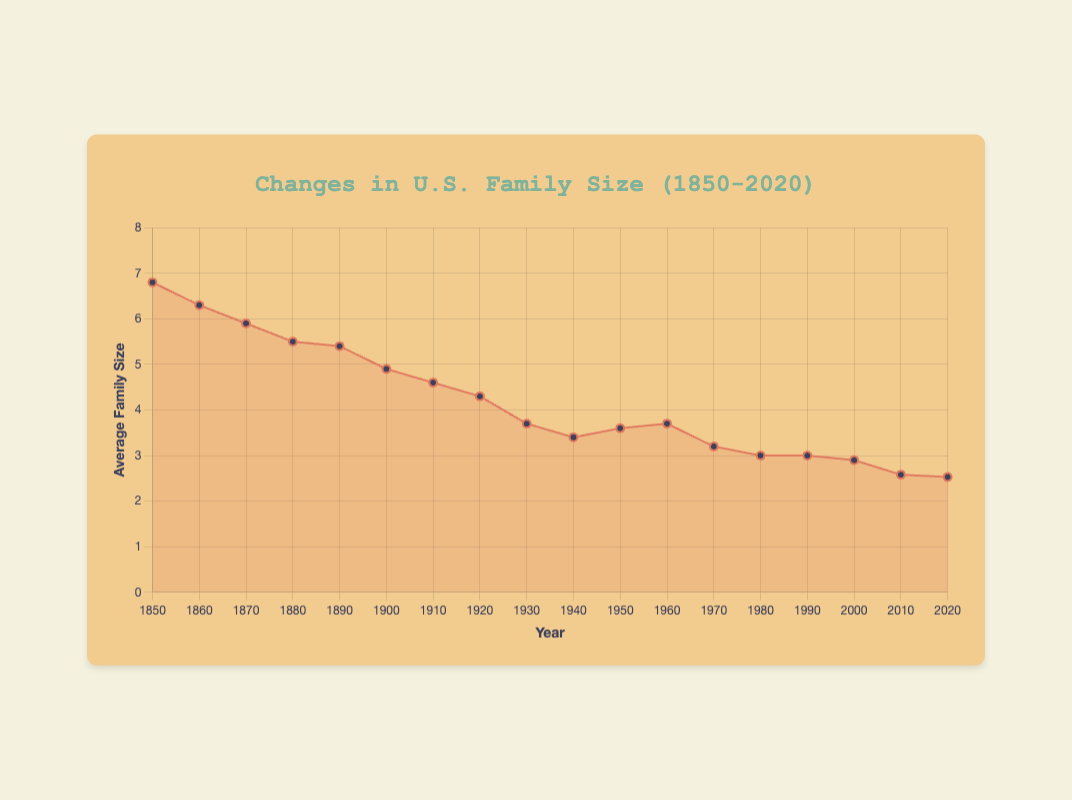What's the average family size in the year 1900? The chart shows the average family size for each decade from 1850 to 2020. By locating the data point corresponding to the year 1900, we can see that the average family size in 1900 was 4.9.
Answer: 4.9 Which year saw the largest decrease in average family size compared to the previous decade? To determine the largest decrease, we must calculate the difference in average family size for each decade and identify the decade with the largest negative difference. The biggest drop is from 1920 to 1930 (4.3 - 3.7 = 0.6).
Answer: 1930 Has the average family size ever increased between two consecutive decades? If yes, when? We need to check if the average family size increased between any two consecutive decades. The only increase is between 1940 and 1950 (3.4 to 3.6) and between 1950 and 1960 (3.6 to 3.7).
Answer: 1950 and 1960 What is the difference in average family size between 1850 and 2020? We must find the values for 1850 and 2020 and calculate their difference. The average family size was 6.8 in 1850 and 2.53 in 2020. The difference is 6.8 - 2.53 = 4.27.
Answer: 4.27 What was the smallest average family size recorded, and in which year did it occur? Looking at the data points, we find that the smallest average family size is 2.53 in 2020.
Answer: 2.53 in 2020 By how much did the average family size decrease from 1850 to 1900? The average family size in 1850 was 6.8, and it was 4.9 in 1900. The decrease is 6.8 - 4.9 = 1.9.
Answer: 1.9 What is the average value of the family sizes between 1950 and 2000? We need to calculate the average of the family sizes from 1950, 1960, 1970, 1980, 1990 and 2000. The values are 3.6, 3.7, 3.2, 3.0, 3.0, and 2.9. (3.6 + 3.7 + 3.2 + 3.0 + 3.0 + 2.9) / 6 = 3.23.
Answer: 3.23 In what period did average family size grow continuously, and by how much did it increase overall during that period? From the chart, the average family size increased between 1940 (3.4) and 1960 (3.7). The total increase is 3.7 - 3.4 = 0.3.
Answer: 1940 to 1960, by 0.3 